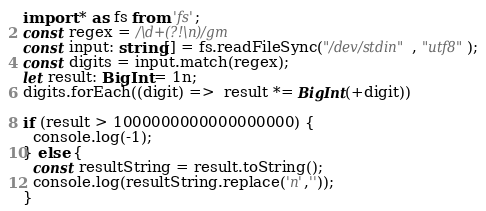<code> <loc_0><loc_0><loc_500><loc_500><_TypeScript_>import * as fs from 'fs';
const regex = /\d+(?!\n)/gm
const input: string[] = fs.readFileSync("/dev/stdin", "utf8");
const digits = input.match(regex);
let result: BigInt = 1n;
digits.forEach((digit) =>  result *= BigInt(+digit))

if (result > 1000000000000000000) {
  console.log(-1);
} else {
  const resultString = result.toString();
  console.log(resultString.replace('n',''));
}</code> 